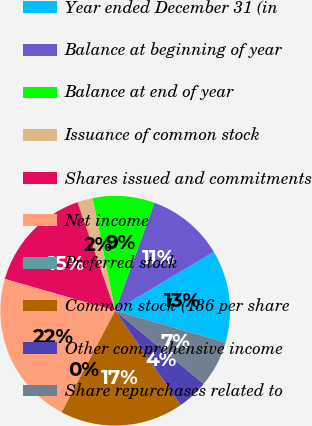Convert chart to OTSL. <chart><loc_0><loc_0><loc_500><loc_500><pie_chart><fcel>Year ended December 31 (in<fcel>Balance at beginning of year<fcel>Balance at end of year<fcel>Issuance of common stock<fcel>Shares issued and commitments<fcel>Net income<fcel>Preferred stock<fcel>Common stock (136 per share<fcel>Other comprehensive income<fcel>Share repurchases related to<nl><fcel>13.04%<fcel>10.87%<fcel>8.7%<fcel>2.18%<fcel>15.21%<fcel>21.73%<fcel>0.01%<fcel>17.38%<fcel>4.35%<fcel>6.53%<nl></chart> 